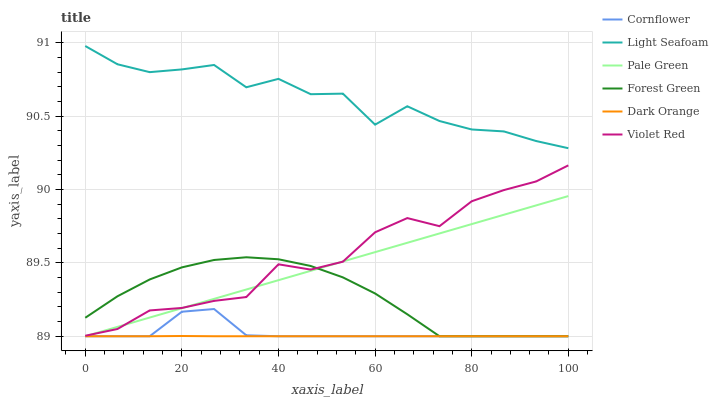Does Dark Orange have the minimum area under the curve?
Answer yes or no. Yes. Does Light Seafoam have the maximum area under the curve?
Answer yes or no. Yes. Does Violet Red have the minimum area under the curve?
Answer yes or no. No. Does Violet Red have the maximum area under the curve?
Answer yes or no. No. Is Pale Green the smoothest?
Answer yes or no. Yes. Is Light Seafoam the roughest?
Answer yes or no. Yes. Is Violet Red the smoothest?
Answer yes or no. No. Is Violet Red the roughest?
Answer yes or no. No. Does Cornflower have the lowest value?
Answer yes or no. Yes. Does Violet Red have the lowest value?
Answer yes or no. No. Does Light Seafoam have the highest value?
Answer yes or no. Yes. Does Violet Red have the highest value?
Answer yes or no. No. Is Cornflower less than Violet Red?
Answer yes or no. Yes. Is Light Seafoam greater than Violet Red?
Answer yes or no. Yes. Does Cornflower intersect Forest Green?
Answer yes or no. Yes. Is Cornflower less than Forest Green?
Answer yes or no. No. Is Cornflower greater than Forest Green?
Answer yes or no. No. Does Cornflower intersect Violet Red?
Answer yes or no. No. 